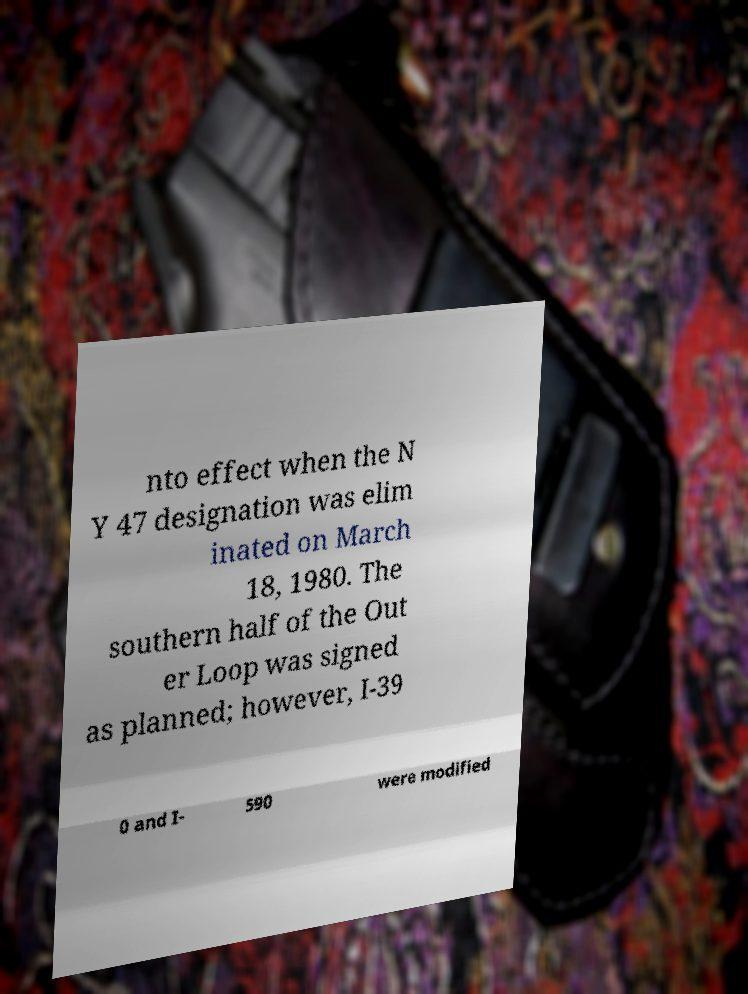Could you extract and type out the text from this image? nto effect when the N Y 47 designation was elim inated on March 18, 1980. The southern half of the Out er Loop was signed as planned; however, I-39 0 and I- 590 were modified 